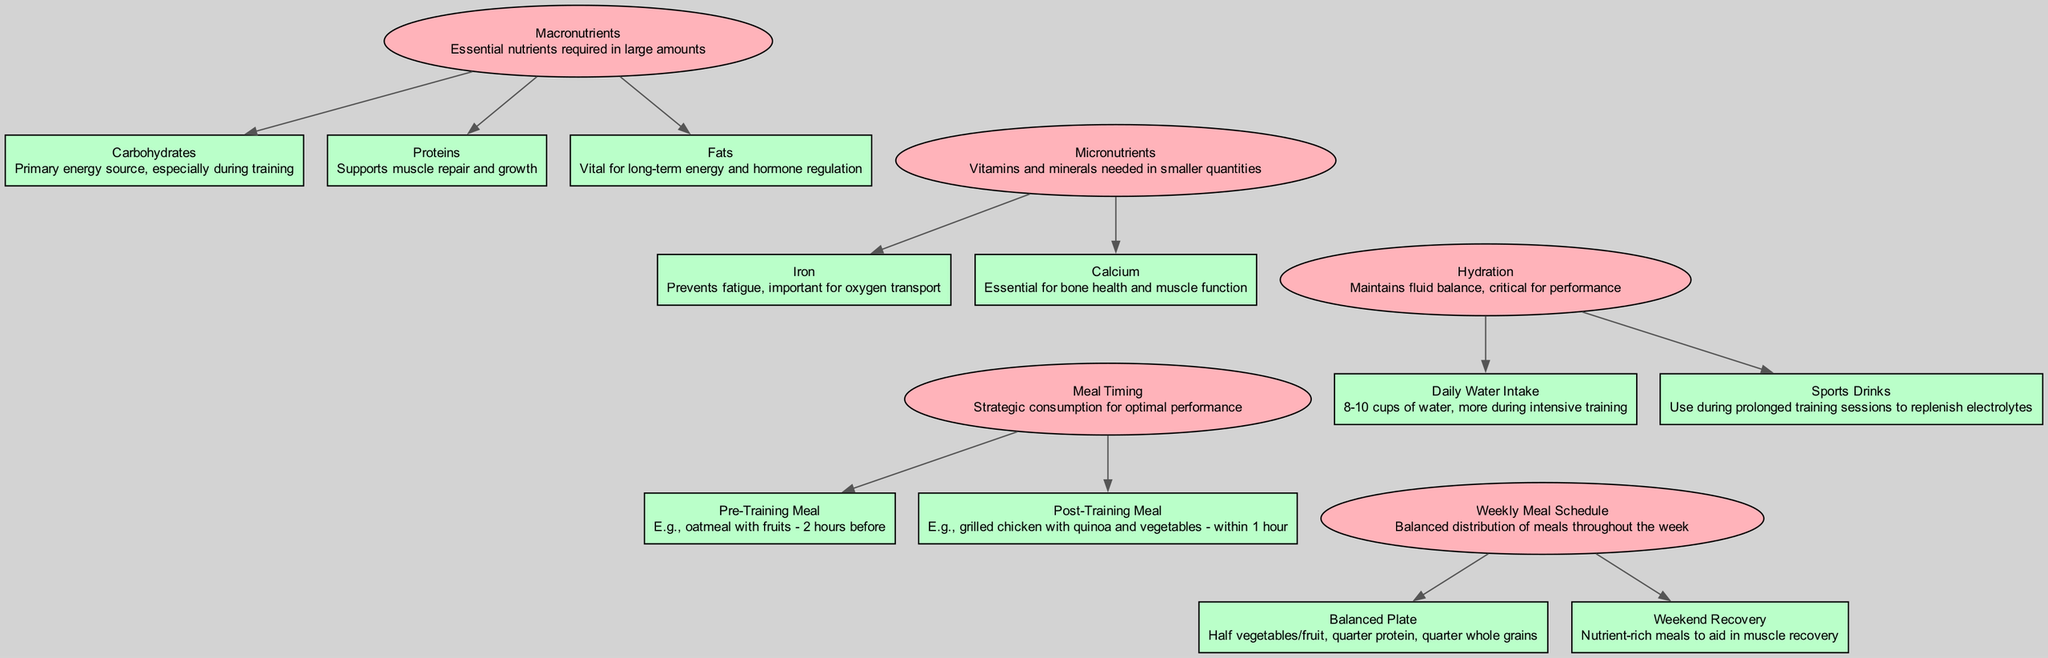What are the three main macronutrients mentioned in the diagram? The diagram lists three main macronutrients: carbohydrates, proteins, and fats, which are identified as the essential nutrients required in large amounts.
Answer: carbohydrates, proteins, fats What is the role of proteins in a developing soccer athlete's nutrition? Proteins are described as supporting muscle repair and growth, which is crucial for a developing athlete's physical performance and recovery.
Answer: Supports muscle repair and growth How many cups of water are recommended for daily intake? The diagram specifies a daily water intake of 8-10 cups, emphasizing that more is needed during intensive training sessions.
Answer: 8-10 cups What type of meal should be consumed two hours before training? The diagram indicates that a pre-training meal could include oatmeal with fruits, providing necessary energy for the upcoming activity.
Answer: Oatmeal with fruits How does hydration contribute to athletic performance? Hydration is described as maintaining fluid balance, which is critical for performance during soccer training and games.
Answer: Maintains fluid balance How many micronutrients are highlighted, and which are they? The diagram highlights two micronutrients: iron and calcium, both of which play important roles in the nutrition of a developing athlete.
Answer: Iron, Calcium What is the purpose of the weekend recovery meals mentioned in the plan? The purpose of weekend recovery meals is to provide nutrient-rich food that aids in muscle recovery after intense training during the week.
Answer: Aid in muscle recovery What is the recommended post-training meal timing? The diagram states that a post-training meal should be consumed within one hour after training to optimize recovery and replenishment.
Answer: Within 1 hour What is the composition of a balanced plate according to the diagram? A balanced plate consists of half vegetables and fruits, a quarter protein, and a quarter whole grains, ensuring a well-rounded diet.
Answer: Half vegetables/fruits, quarter protein, quarter whole grains 